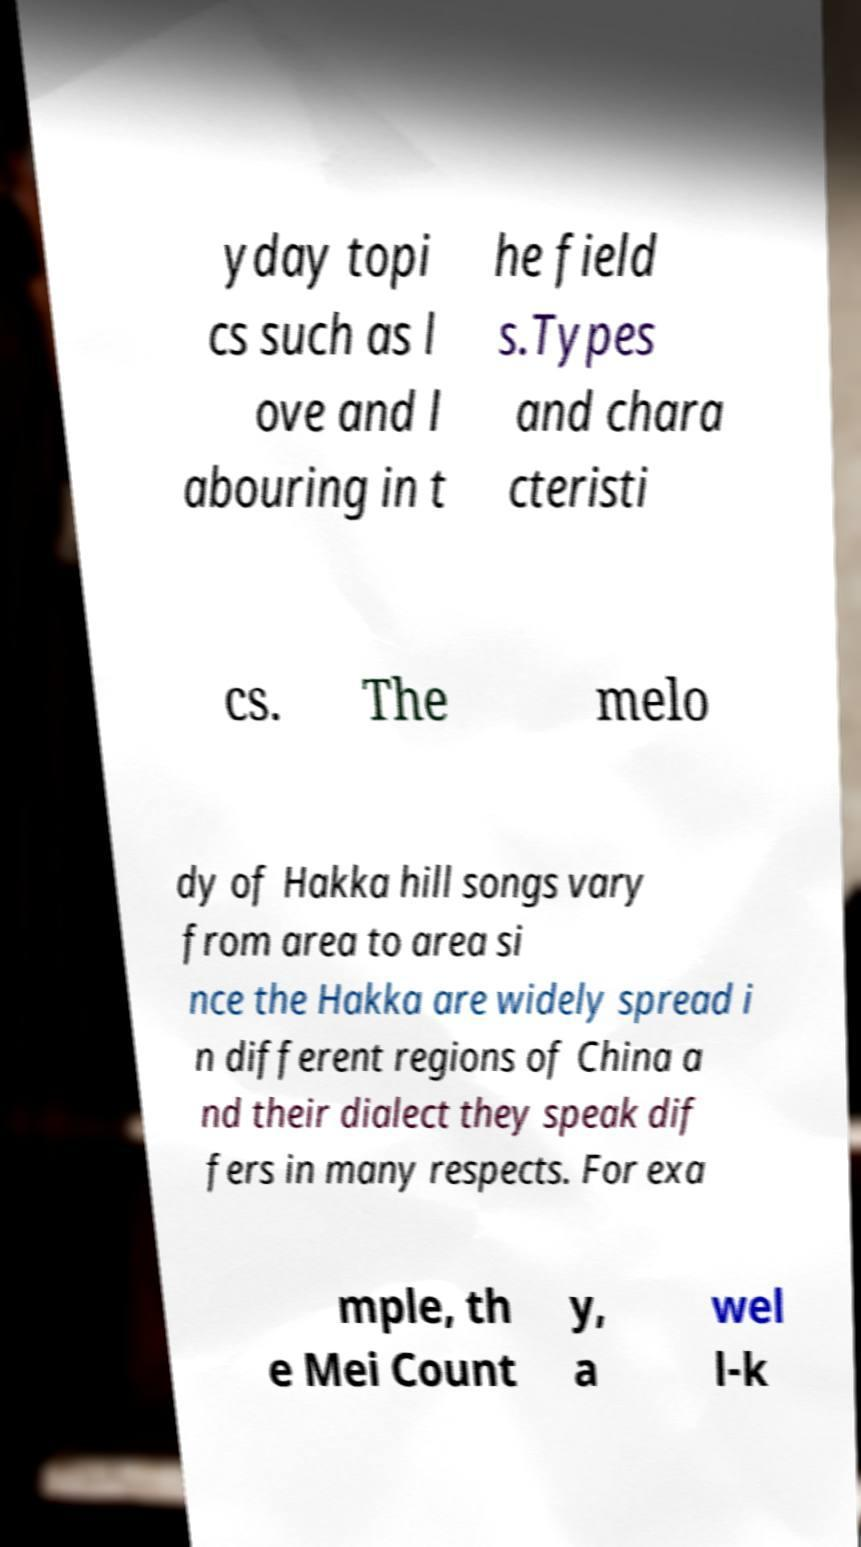I need the written content from this picture converted into text. Can you do that? yday topi cs such as l ove and l abouring in t he field s.Types and chara cteristi cs. The melo dy of Hakka hill songs vary from area to area si nce the Hakka are widely spread i n different regions of China a nd their dialect they speak dif fers in many respects. For exa mple, th e Mei Count y, a wel l-k 